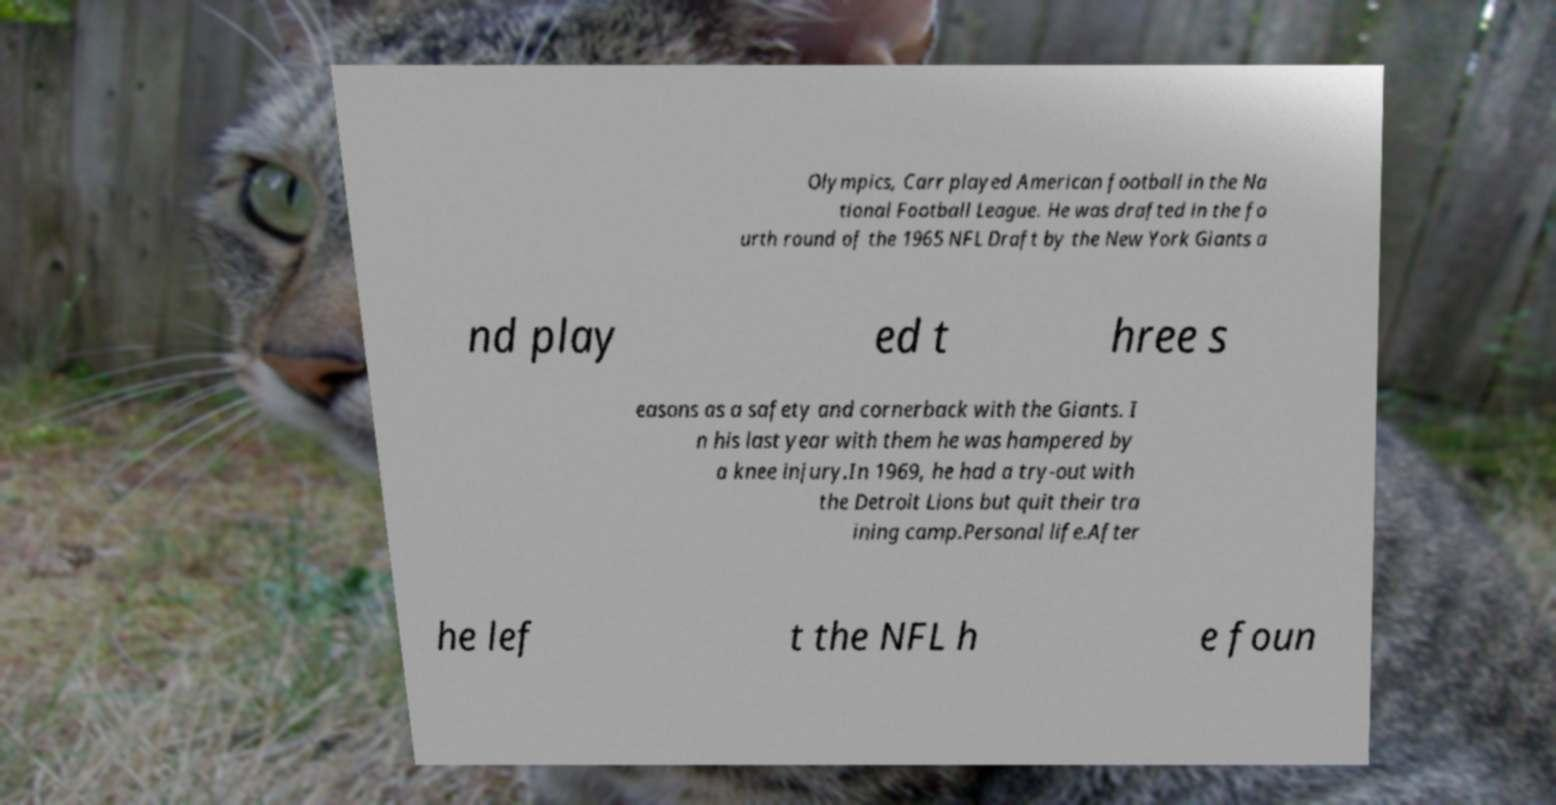Could you extract and type out the text from this image? Olympics, Carr played American football in the Na tional Football League. He was drafted in the fo urth round of the 1965 NFL Draft by the New York Giants a nd play ed t hree s easons as a safety and cornerback with the Giants. I n his last year with them he was hampered by a knee injury.In 1969, he had a try-out with the Detroit Lions but quit their tra ining camp.Personal life.After he lef t the NFL h e foun 